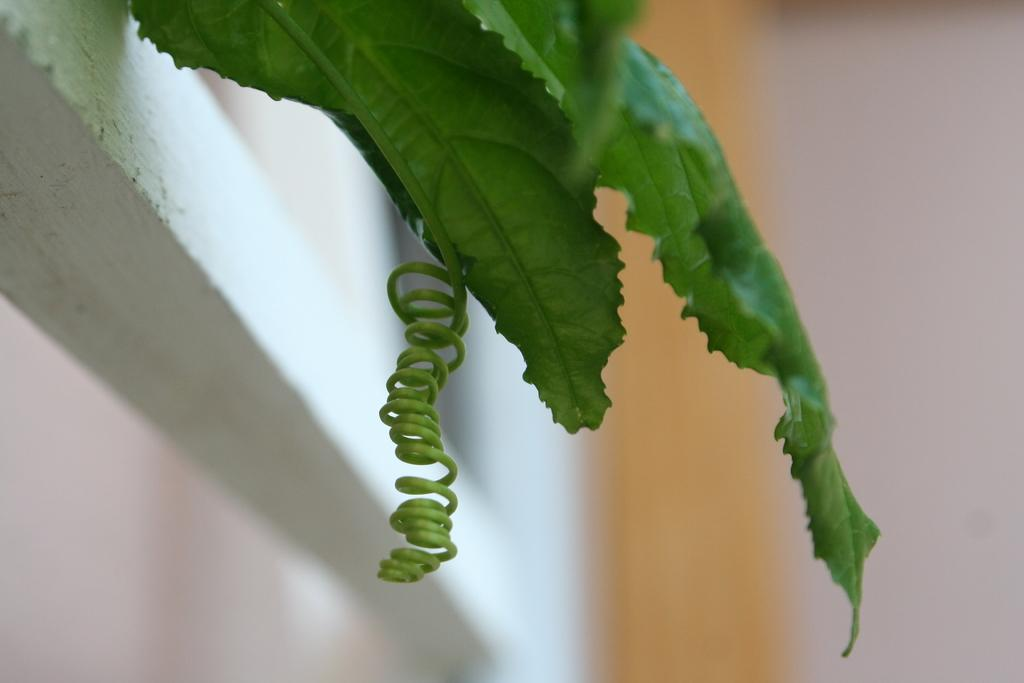What type of vegetation is present in the image? There are green leaves in the image. What is the unique feature of the twig in the image? The twig in the image has a spiral shape. Where is the spiral twig located? The spiral twig is hanging from a white wall. How many goldfish can be seen swimming in the image? There are no goldfish present in the image. What type of baby is visible in the image? There is no baby present in the image. 